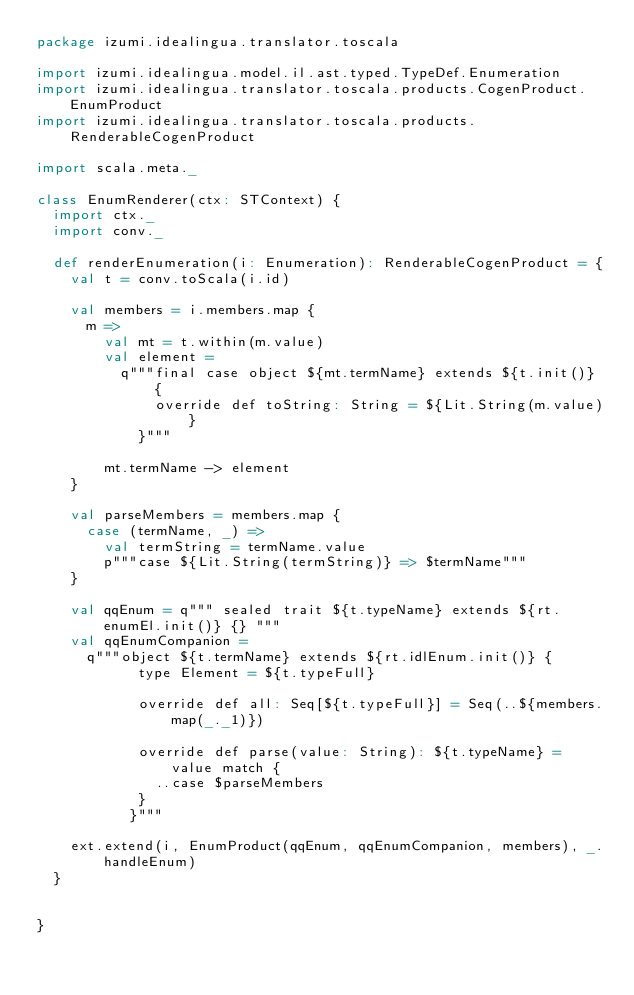<code> <loc_0><loc_0><loc_500><loc_500><_Scala_>package izumi.idealingua.translator.toscala

import izumi.idealingua.model.il.ast.typed.TypeDef.Enumeration
import izumi.idealingua.translator.toscala.products.CogenProduct.EnumProduct
import izumi.idealingua.translator.toscala.products.RenderableCogenProduct

import scala.meta._

class EnumRenderer(ctx: STContext) {
  import ctx._
  import conv._

  def renderEnumeration(i: Enumeration): RenderableCogenProduct = {
    val t = conv.toScala(i.id)

    val members = i.members.map {
      m =>
        val mt = t.within(m.value)
        val element =
          q"""final case object ${mt.termName} extends ${t.init()} {
              override def toString: String = ${Lit.String(m.value)}
            }"""

        mt.termName -> element
    }

    val parseMembers = members.map {
      case (termName, _) =>
        val termString = termName.value
        p"""case ${Lit.String(termString)} => $termName"""
    }

    val qqEnum = q""" sealed trait ${t.typeName} extends ${rt.enumEl.init()} {} """
    val qqEnumCompanion =
      q"""object ${t.termName} extends ${rt.idlEnum.init()} {
            type Element = ${t.typeFull}

            override def all: Seq[${t.typeFull}] = Seq(..${members.map(_._1)})

            override def parse(value: String): ${t.typeName} = value match {
              ..case $parseMembers
            }
           }"""

    ext.extend(i, EnumProduct(qqEnum, qqEnumCompanion, members), _.handleEnum)
  }


}
</code> 